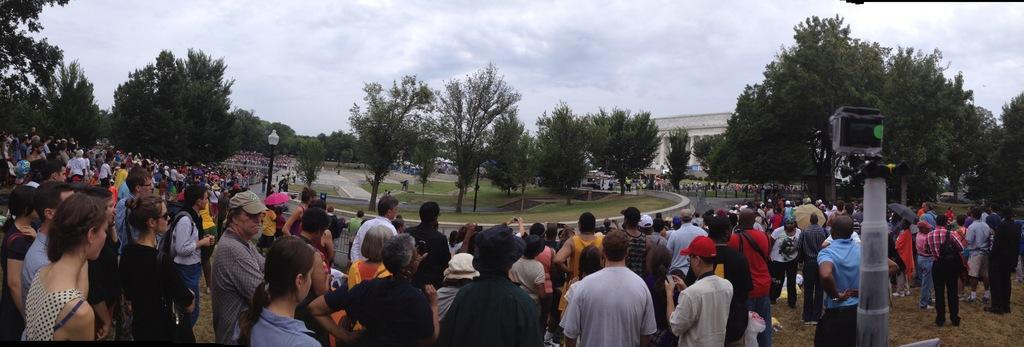What are the people in the image doing? The group of people is standing on the ground in the image. What type of vegetation can be seen in the image? Trees are present in the image. What structures can be seen in the image? Poles and a building are visible in the image. What is the ground made of in the image? Grass is present in the image. What is visible in the background of the image? The sky is visible in the background of the image. What can be seen in the sky in the image? Clouds are present in the sky. Can you see a mountain in the background of the image? There is no mountain present in the image. Is there a bike visible in the image? There is no bike present in the image. 